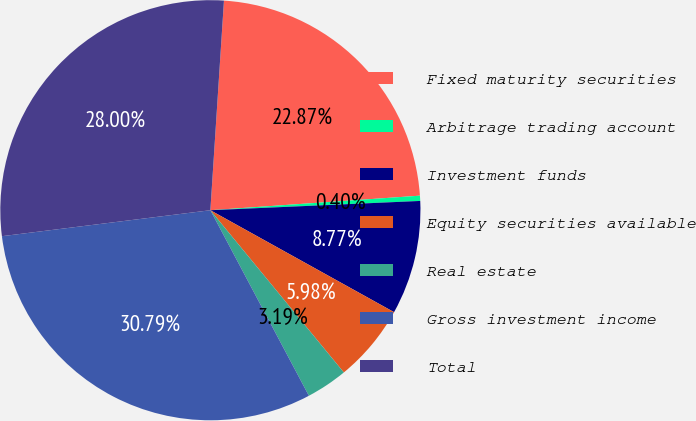Convert chart to OTSL. <chart><loc_0><loc_0><loc_500><loc_500><pie_chart><fcel>Fixed maturity securities<fcel>Arbitrage trading account<fcel>Investment funds<fcel>Equity securities available<fcel>Real estate<fcel>Gross investment income<fcel>Total<nl><fcel>22.87%<fcel>0.4%<fcel>8.77%<fcel>5.98%<fcel>3.19%<fcel>30.8%<fcel>28.01%<nl></chart> 